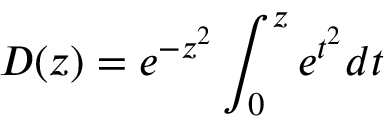Convert formula to latex. <formula><loc_0><loc_0><loc_500><loc_500>D ( z ) = e ^ { - z ^ { 2 } } \int _ { 0 } ^ { z } e ^ { t ^ { 2 } } d t</formula> 